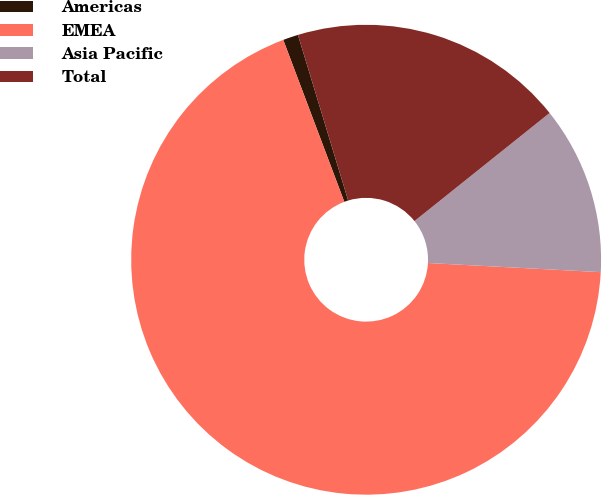<chart> <loc_0><loc_0><loc_500><loc_500><pie_chart><fcel>Americas<fcel>EMEA<fcel>Asia Pacific<fcel>Total<nl><fcel>1.05%<fcel>68.42%<fcel>11.58%<fcel>18.95%<nl></chart> 